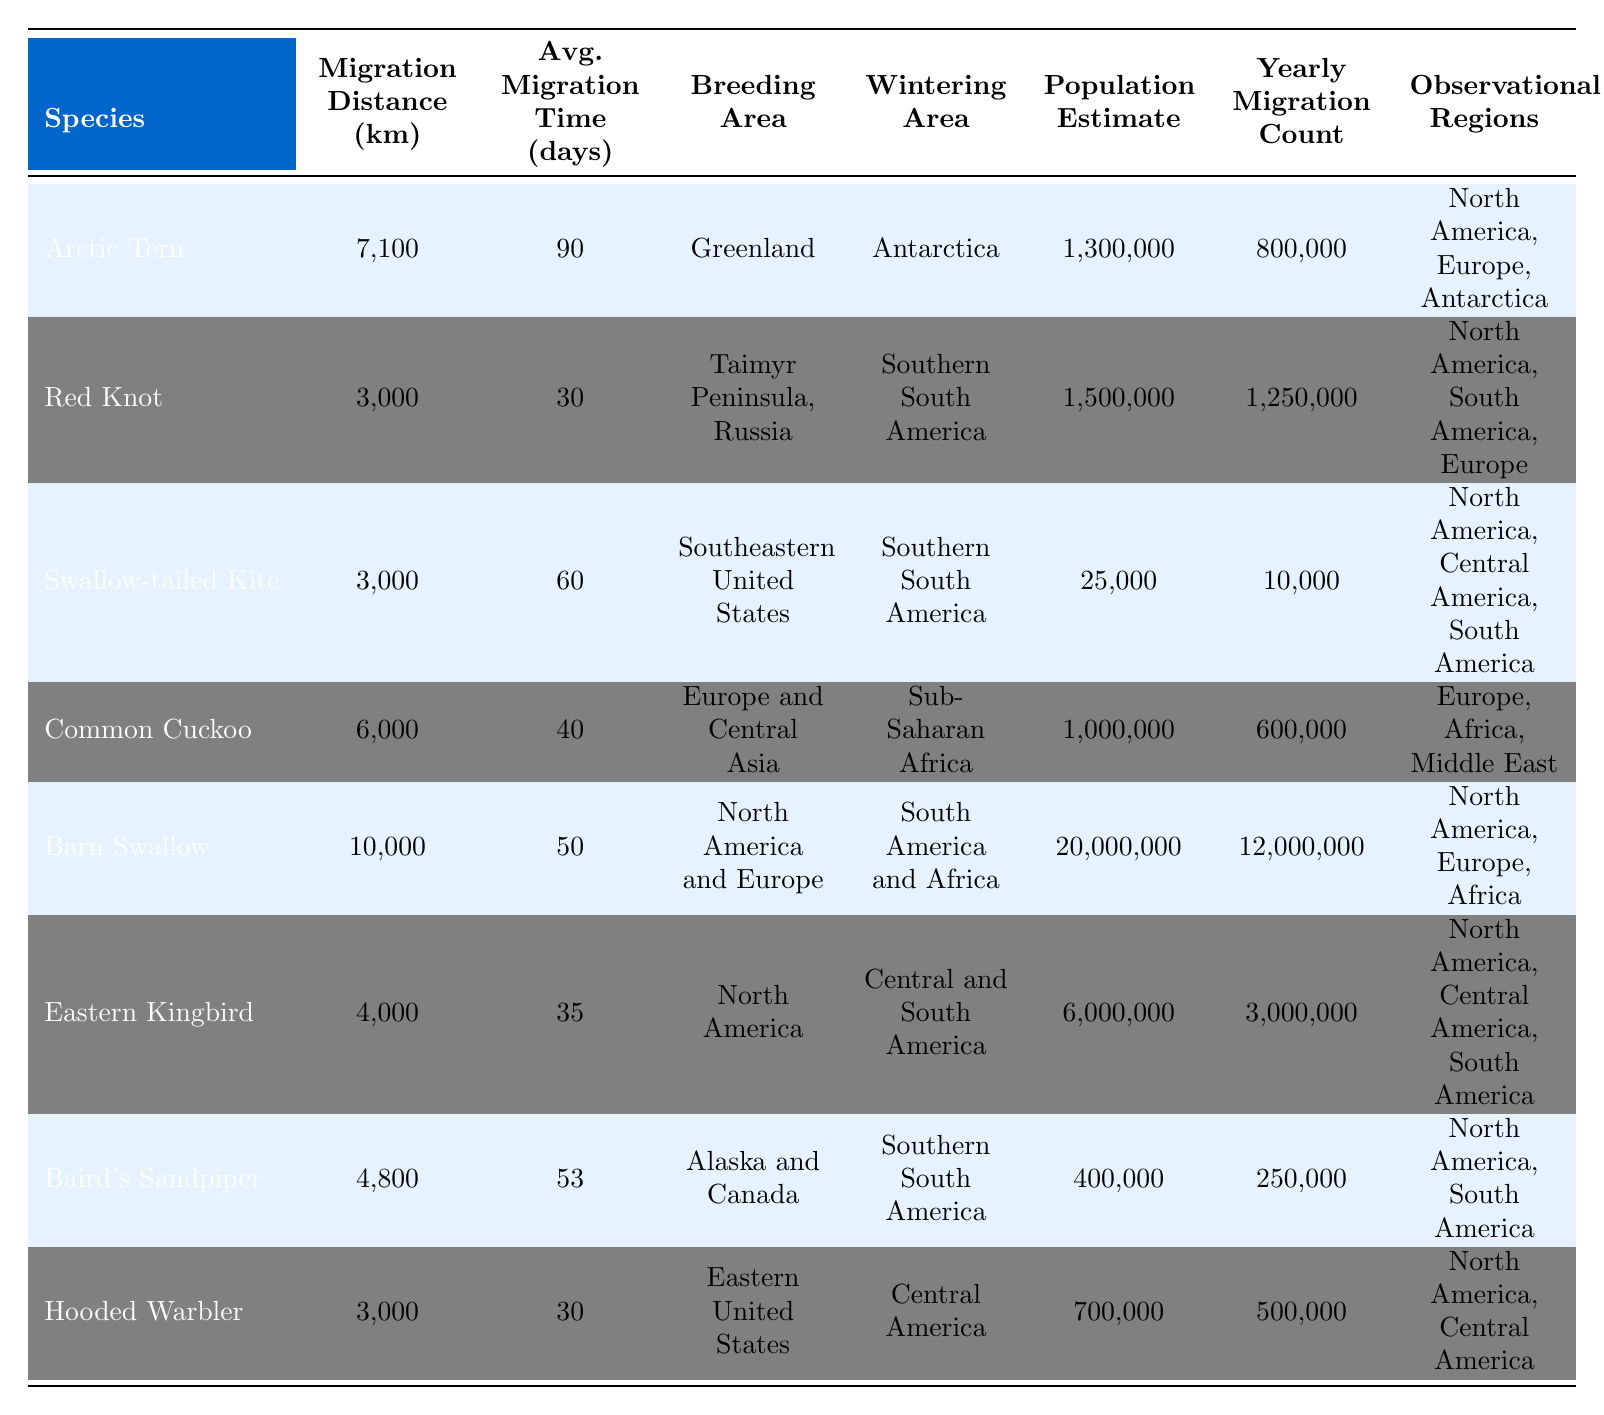What is the migration distance of the Barn Swallow? The table lists the Barn Swallow with a migration distance of 10,000 km.
Answer: 10,000 km Which bird species has the longest average migration time? By examining the "Avg. Migration Time (days)" column, the Arctic Tern has an average migration time of 90 days, which is the longest among the species listed.
Answer: Arctic Tern How many bird species have a migration distance less than 4,000 km? The species that meet this criterion are the Red Knot, Swallow-tailed Kite, and Hooded Warbler, totaling 3 species.
Answer: 3 Is the population estimate of the Common Cuckoo greater than that of the Baird's Sandpiper? The population estimate of the Common Cuckoo is 1,000,000, while that of the Baird's Sandpiper is 400,000. Since 1,000,000 is greater than 400,000, this statement is true.
Answer: Yes What is the total yearly migration count for all species listed? Adding the yearly migration counts: 800,000 + 1,250,000 + 10,000 + 600,000 + 12,000,000 + 3,000,000 + 250,000 + 500,000 = 18,412,000.
Answer: 18,412,000 Which species has the shortest migration distance and what is that distance? The Red Knot and Swallow-tailed Kite both have a migration distance of 3,000 km, which is the shortest distance among all species.
Answer: 3,000 km How many species have their breeding area in North America? The species with breeding areas in North America are the Barn Swallow, Eastern Kingbird, Swallow-tailed Kite, and Hooded Warbler, totaling 4 species.
Answer: 4 Is the average migration time of the Eastern Kingbird higher than that of the Hooded Warbler? The Eastern Kingbird has an average migration time of 35 days, while the Hooded Warbler has 30 days. Therefore, yes, the Eastern Kingbird has a higher average migration time.
Answer: Yes What is the difference in population estimates between the Barn Swallow and the Swallow-tailed Kite? The population estimate for the Barn Swallow is 20,000,000 and for the Swallow-tailed Kite is 25,000. By calculating, 20,000,000 - 25,000 = 19,975,000.
Answer: 19,975,000 Which bird species covers a migration distance greater than 6,000 km during migration? The Arctic Tern and Barn Swallow are the species that migrate more than 6,000 km, with distances of 7,100 km and 10,000 km, respectively.
Answer: 2 species What is the average migration distance of all the species listed? We calculate the average by summing the distances of all species: (7100 + 3000 + 3000 + 6000 + 10000 + 4000 + 4800 + 3000) = 35,900 km, then dividing by 8 species gives an average of 4,487.5 km.
Answer: 4,487.5 km 